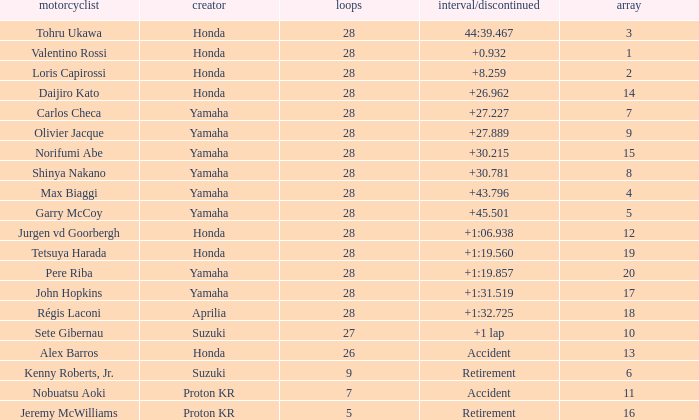How many laps did pere riba ride? 28.0. 